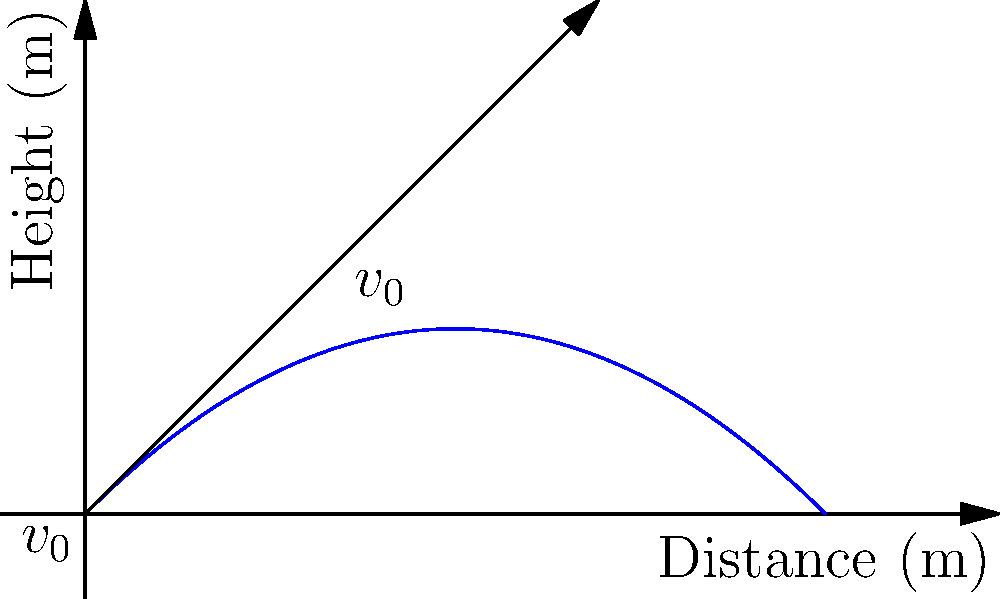As an experienced farmer using sustainable irrigation techniques, you're analyzing the trajectory of water droplets from your new sprinkler system. The initial velocity of the water droplets is 10 m/s at an angle of 45° to the horizontal. Assuming air resistance is negligible, what is the maximum height reached by the water droplets? To find the maximum height of the water droplets, we'll follow these steps:

1) The initial velocity components are:
   $v_{0x} = v_0 \cos \theta = 10 \cos 45° = 10 \cdot \frac{\sqrt{2}}{2} \approx 7.07$ m/s
   $v_{0y} = v_0 \sin \theta = 10 \sin 45° = 10 \cdot \frac{\sqrt{2}}{2} \approx 7.07$ m/s

2) The time to reach maximum height is when the vertical velocity becomes zero:
   $v_y = v_{0y} - gt = 0$
   $t = \frac{v_{0y}}{g} = \frac{7.07}{9.8} \approx 0.72$ s

3) The maximum height can be calculated using the equation:
   $y = v_{0y}t - \frac{1}{2}gt^2$

4) Substituting the values:
   $y_{max} = (7.07)(0.72) - \frac{1}{2}(9.8)(0.72)^2$
   $y_{max} = 5.09 - 2.54 = 2.55$ m

Therefore, the maximum height reached by the water droplets is approximately 2.55 meters.
Answer: 2.55 m 